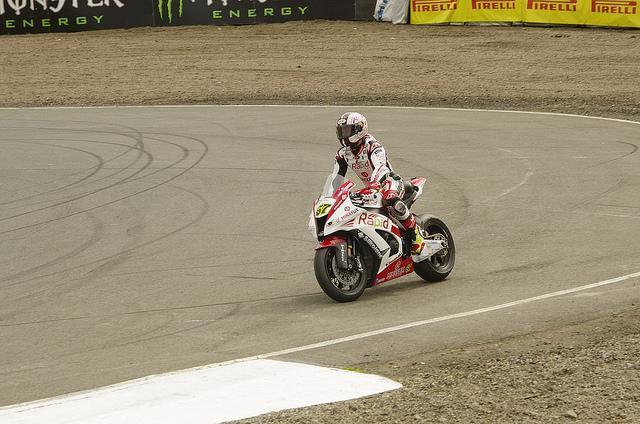How many times does "energy" appear in the picture?
Give a very brief answer. 2. How many motorcycles pictured?
Give a very brief answer. 1. How many bikes are seen?
Give a very brief answer. 1. How many red chairs are in this image?
Give a very brief answer. 0. 